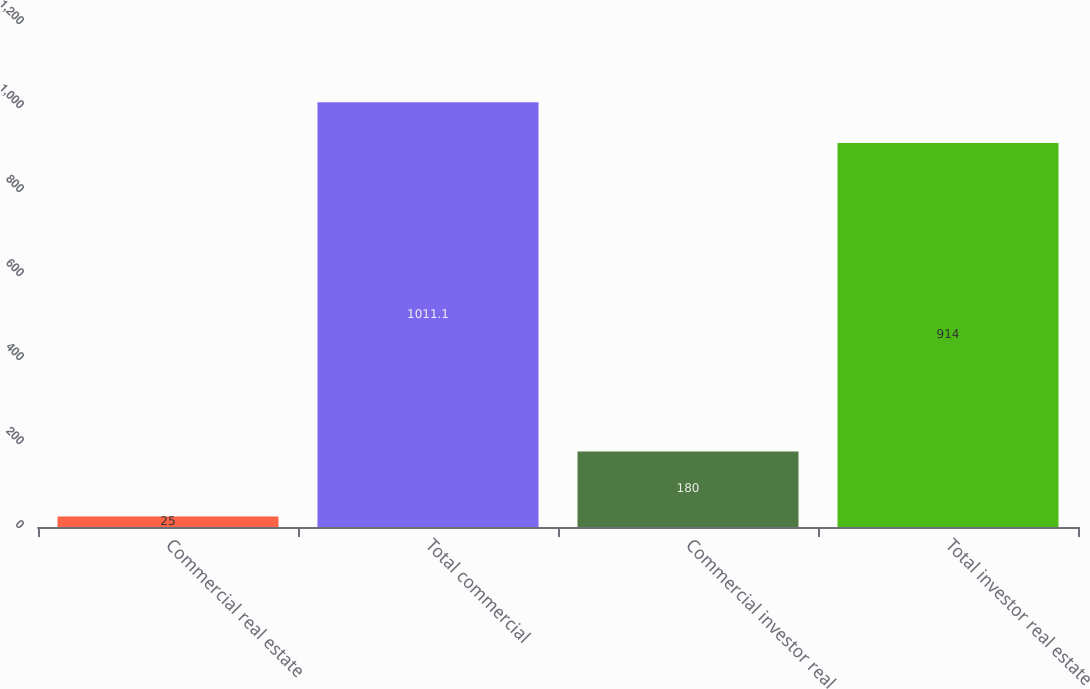<chart> <loc_0><loc_0><loc_500><loc_500><bar_chart><fcel>Commercial real estate<fcel>Total commercial<fcel>Commercial investor real<fcel>Total investor real estate<nl><fcel>25<fcel>1011.1<fcel>180<fcel>914<nl></chart> 